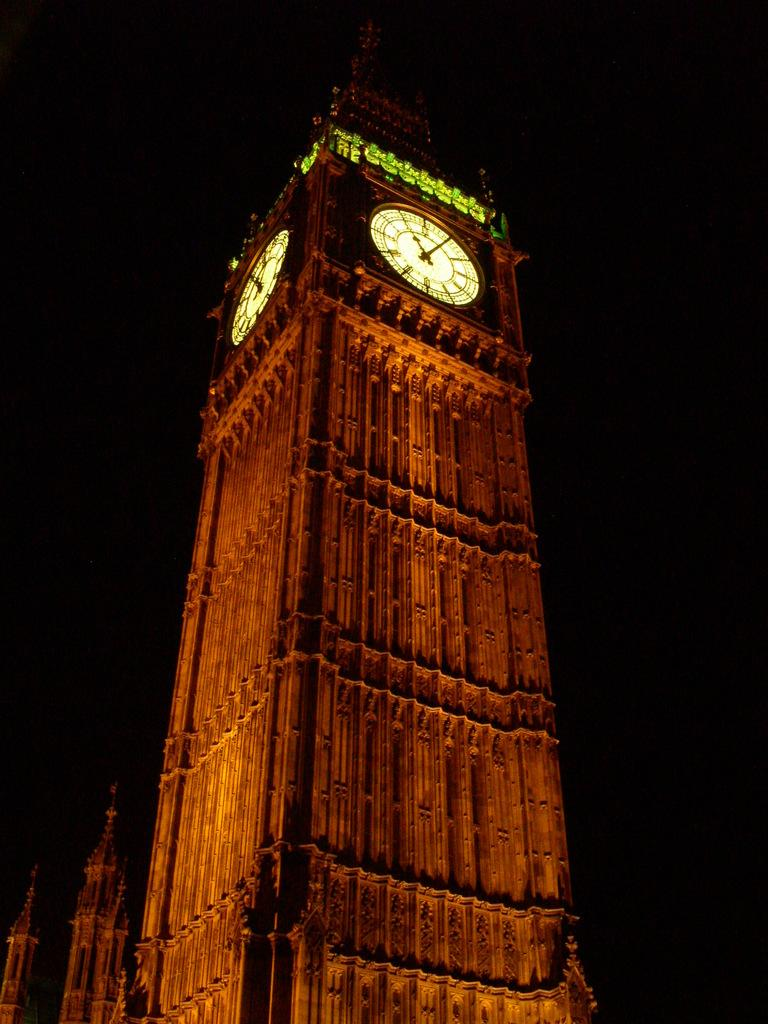What type of structures are present in the image? There is a group of buildings in the image. What specific feature can be seen in the foreground of the image? There is a tower with clocks in the foreground of the image. What part of the natural environment is visible in the image? The sky is visible in the background of the image. Can you hear the horses crying in the image? There are no horses or any sounds mentioned in the image, so it is not possible to determine if they are crying. 